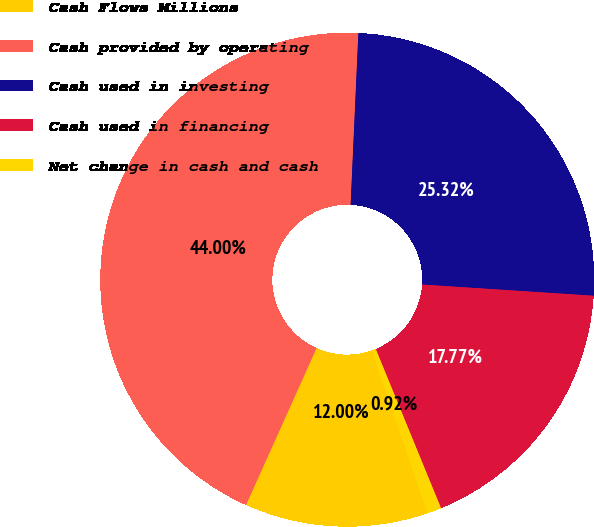<chart> <loc_0><loc_0><loc_500><loc_500><pie_chart><fcel>Cash Flows Millions<fcel>Cash provided by operating<fcel>Cash used in investing<fcel>Cash used in financing<fcel>Net change in cash and cash<nl><fcel>12.0%<fcel>44.0%<fcel>25.32%<fcel>17.77%<fcel>0.92%<nl></chart> 